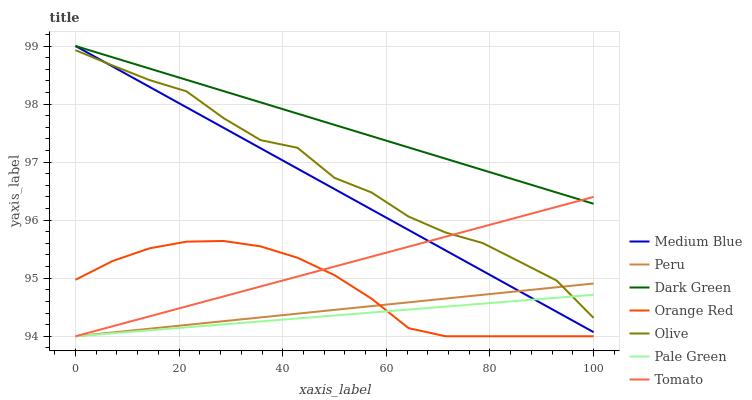Does Pale Green have the minimum area under the curve?
Answer yes or no. Yes. Does Dark Green have the maximum area under the curve?
Answer yes or no. Yes. Does Medium Blue have the minimum area under the curve?
Answer yes or no. No. Does Medium Blue have the maximum area under the curve?
Answer yes or no. No. Is Peru the smoothest?
Answer yes or no. Yes. Is Olive the roughest?
Answer yes or no. Yes. Is Medium Blue the smoothest?
Answer yes or no. No. Is Medium Blue the roughest?
Answer yes or no. No. Does Tomato have the lowest value?
Answer yes or no. Yes. Does Medium Blue have the lowest value?
Answer yes or no. No. Does Dark Green have the highest value?
Answer yes or no. Yes. Does Pale Green have the highest value?
Answer yes or no. No. Is Orange Red less than Medium Blue?
Answer yes or no. Yes. Is Olive greater than Orange Red?
Answer yes or no. Yes. Does Olive intersect Pale Green?
Answer yes or no. Yes. Is Olive less than Pale Green?
Answer yes or no. No. Is Olive greater than Pale Green?
Answer yes or no. No. Does Orange Red intersect Medium Blue?
Answer yes or no. No. 